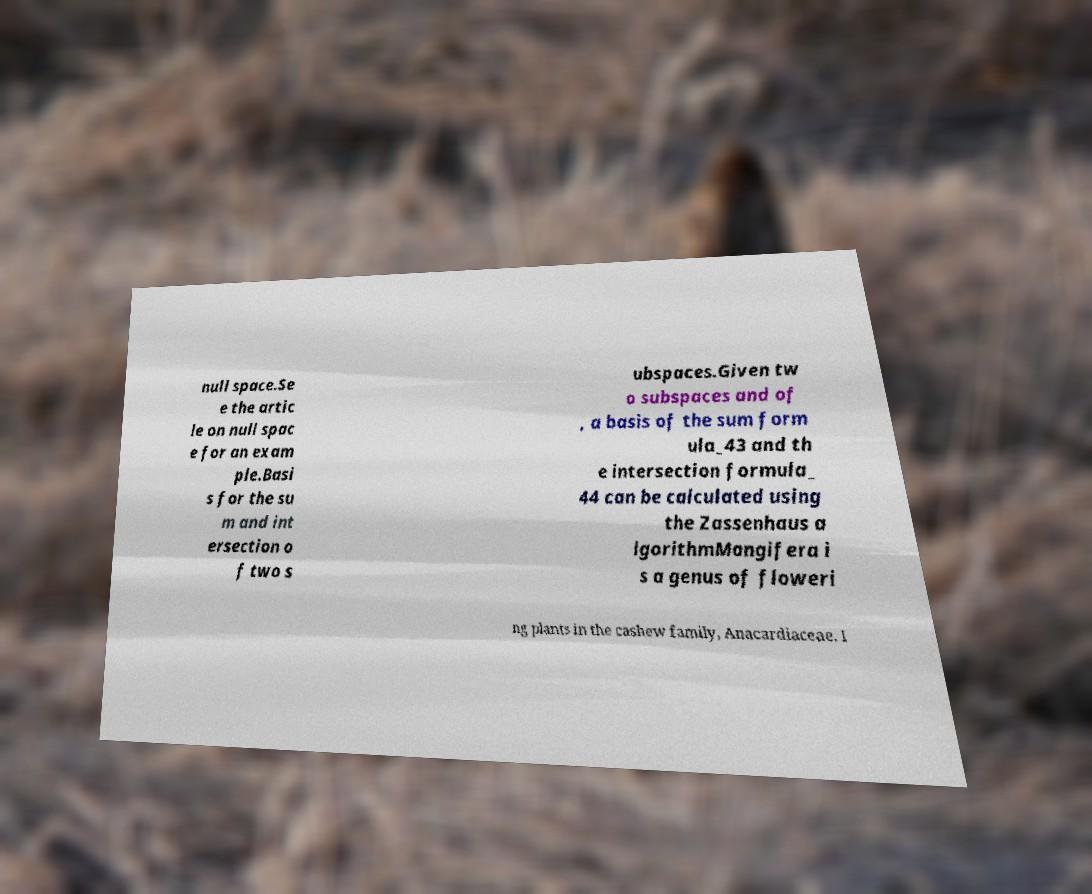There's text embedded in this image that I need extracted. Can you transcribe it verbatim? null space.Se e the artic le on null spac e for an exam ple.Basi s for the su m and int ersection o f two s ubspaces.Given tw o subspaces and of , a basis of the sum form ula_43 and th e intersection formula_ 44 can be calculated using the Zassenhaus a lgorithmMangifera i s a genus of floweri ng plants in the cashew family, Anacardiaceae. I 